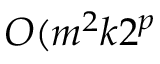<formula> <loc_0><loc_0><loc_500><loc_500>O ( m ^ { 2 } k 2 ^ { p }</formula> 